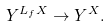<formula> <loc_0><loc_0><loc_500><loc_500>Y ^ { L _ { f } X } \to Y ^ { X } .</formula> 